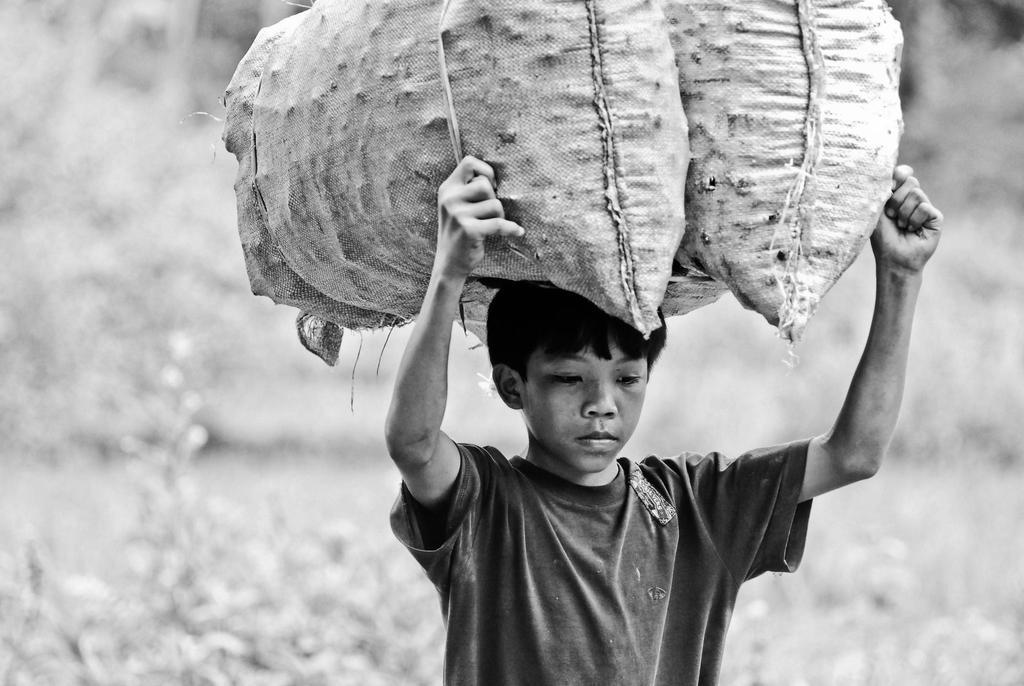Who is the main subject in the picture? There is a boy in the picture. What is the boy doing in the image? The boy is holding two bags on his head. What is the boy wearing in the picture? The boy is wearing a T-shirt. What type of cracker is the boy feeding to the animals at the zoo in the image? There is no zoo, animals, or crackers present in the image. The boy is simply holding two bags on his head. 